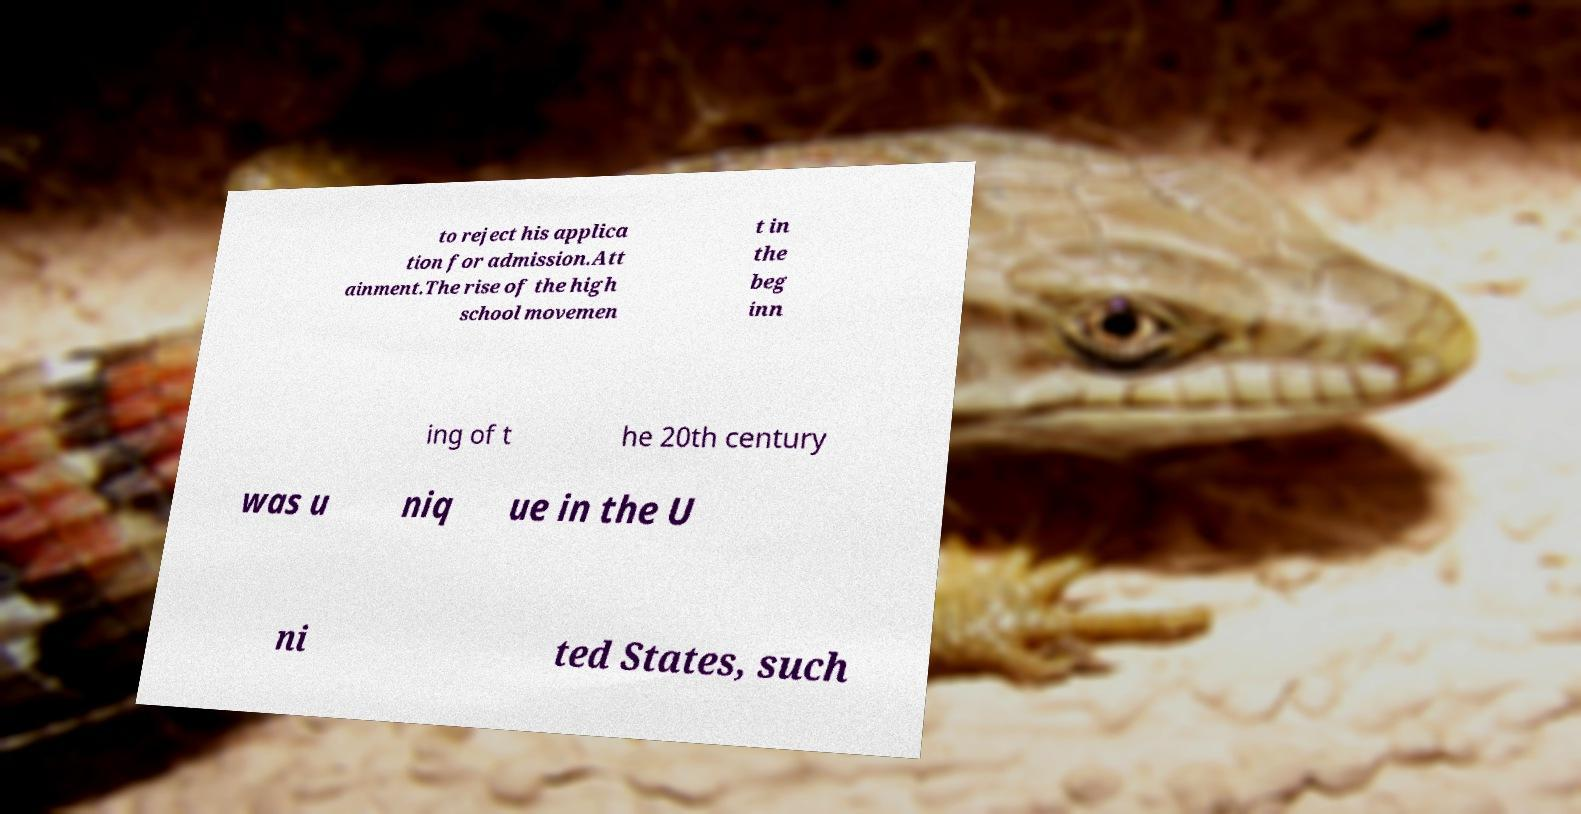I need the written content from this picture converted into text. Can you do that? to reject his applica tion for admission.Att ainment.The rise of the high school movemen t in the beg inn ing of t he 20th century was u niq ue in the U ni ted States, such 